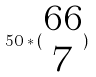<formula> <loc_0><loc_0><loc_500><loc_500>5 0 * ( \begin{matrix} 6 6 \\ 7 \end{matrix} )</formula> 